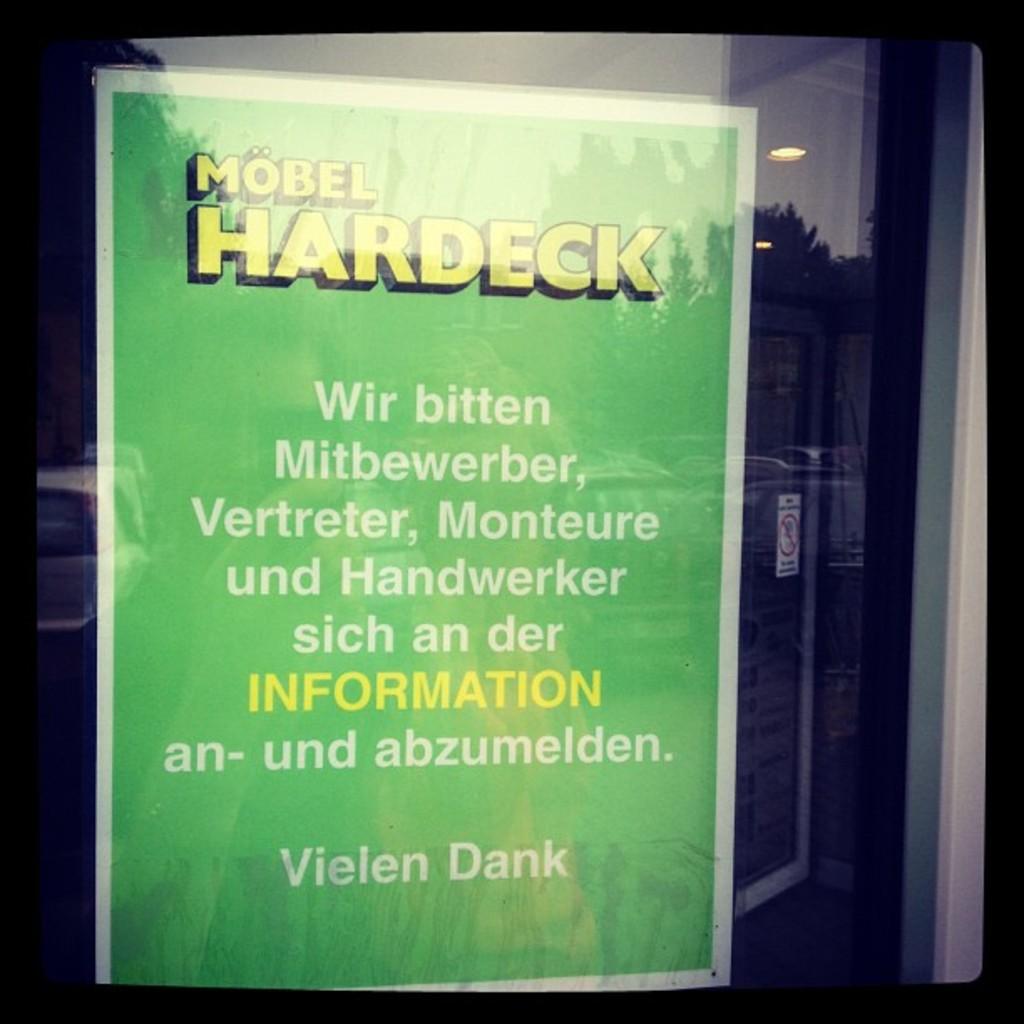Who wrote this book?
Make the answer very short. Vielen dank. Who's name is at the bottom of the poster?
Ensure brevity in your answer.  Vielen dank. 